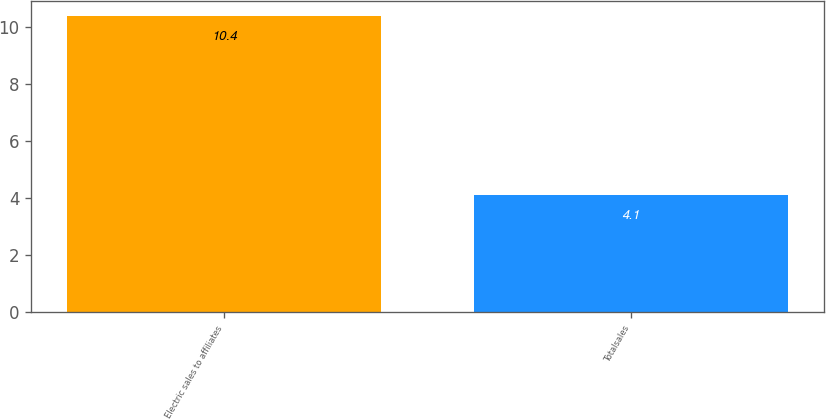<chart> <loc_0><loc_0><loc_500><loc_500><bar_chart><fcel>Electric sales to affiliates<fcel>Totalsales<nl><fcel>10.4<fcel>4.1<nl></chart> 